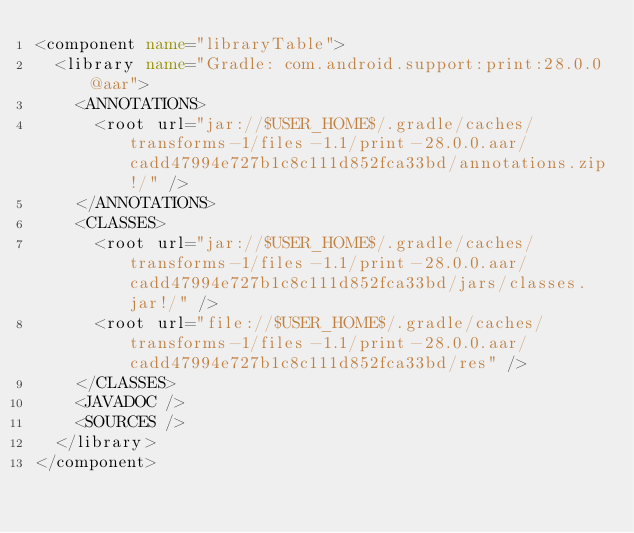Convert code to text. <code><loc_0><loc_0><loc_500><loc_500><_XML_><component name="libraryTable">
  <library name="Gradle: com.android.support:print:28.0.0@aar">
    <ANNOTATIONS>
      <root url="jar://$USER_HOME$/.gradle/caches/transforms-1/files-1.1/print-28.0.0.aar/cadd47994e727b1c8c111d852fca33bd/annotations.zip!/" />
    </ANNOTATIONS>
    <CLASSES>
      <root url="jar://$USER_HOME$/.gradle/caches/transforms-1/files-1.1/print-28.0.0.aar/cadd47994e727b1c8c111d852fca33bd/jars/classes.jar!/" />
      <root url="file://$USER_HOME$/.gradle/caches/transforms-1/files-1.1/print-28.0.0.aar/cadd47994e727b1c8c111d852fca33bd/res" />
    </CLASSES>
    <JAVADOC />
    <SOURCES />
  </library>
</component></code> 